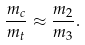<formula> <loc_0><loc_0><loc_500><loc_500>\frac { m _ { c } } { m _ { t } } \approx \frac { m _ { 2 } } { m _ { 3 } } .</formula> 